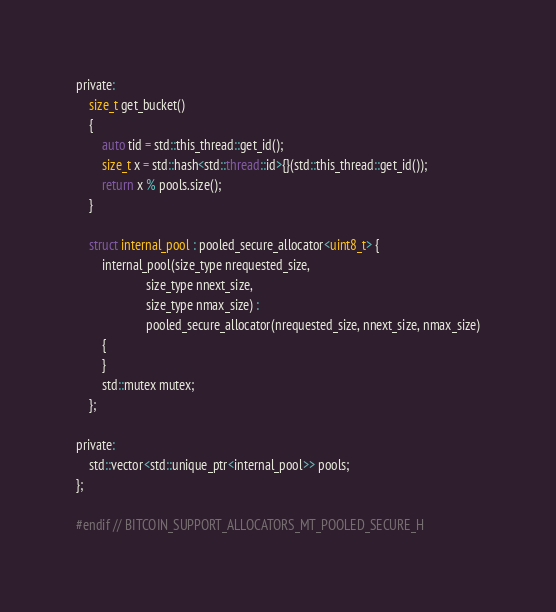<code> <loc_0><loc_0><loc_500><loc_500><_C_>
private:
    size_t get_bucket()
    {
        auto tid = std::this_thread::get_id();
        size_t x = std::hash<std::thread::id>{}(std::this_thread::get_id());
        return x % pools.size();
    }

    struct internal_pool : pooled_secure_allocator<uint8_t> {
        internal_pool(size_type nrequested_size,
                      size_type nnext_size,
                      size_type nmax_size) :
                      pooled_secure_allocator(nrequested_size, nnext_size, nmax_size)
        {
        }
        std::mutex mutex;
    };

private:
    std::vector<std::unique_ptr<internal_pool>> pools;
};

#endif // BITCOIN_SUPPORT_ALLOCATORS_MT_POOLED_SECURE_H
</code> 